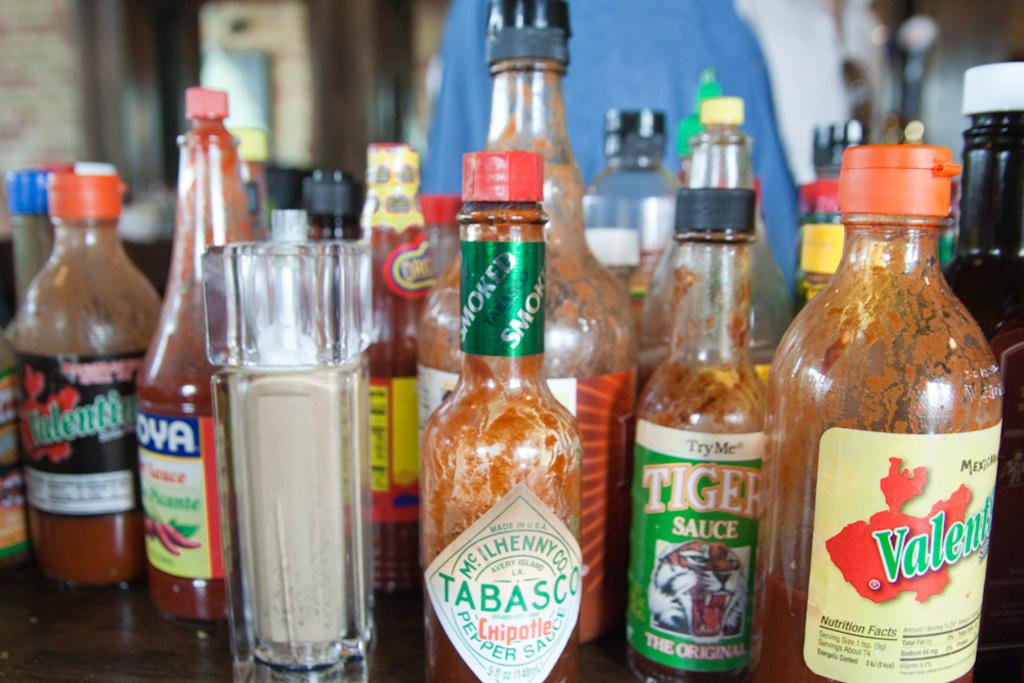What type of objects are present in the image? There are many glass bottles in the image. Can you describe the label on the front bottle? The front bottle has "Tabasco pepper sauce" written on it. What type of mint plant can be seen growing in the image? There is no mint plant present in the image; it only features glass bottles with labels. 